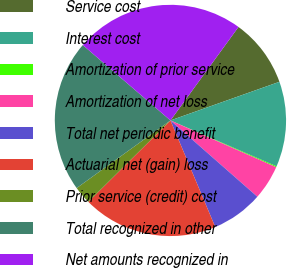<chart> <loc_0><loc_0><loc_500><loc_500><pie_chart><fcel>Service cost<fcel>Interest cost<fcel>Amortization of prior service<fcel>Amortization of net loss<fcel>Total net periodic benefit<fcel>Actuarial net (gain) loss<fcel>Prior service (credit) cost<fcel>Total recognized in other<fcel>Net amounts recognized in<nl><fcel>9.56%<fcel>11.92%<fcel>0.13%<fcel>4.84%<fcel>7.2%<fcel>18.9%<fcel>2.49%<fcel>21.25%<fcel>23.71%<nl></chart> 